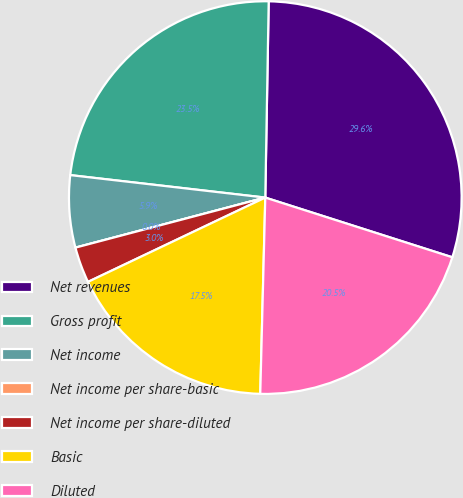<chart> <loc_0><loc_0><loc_500><loc_500><pie_chart><fcel>Net revenues<fcel>Gross profit<fcel>Net income<fcel>Net income per share-basic<fcel>Net income per share-diluted<fcel>Basic<fcel>Diluted<nl><fcel>29.64%<fcel>23.45%<fcel>5.93%<fcel>0.0%<fcel>2.96%<fcel>17.53%<fcel>20.49%<nl></chart> 